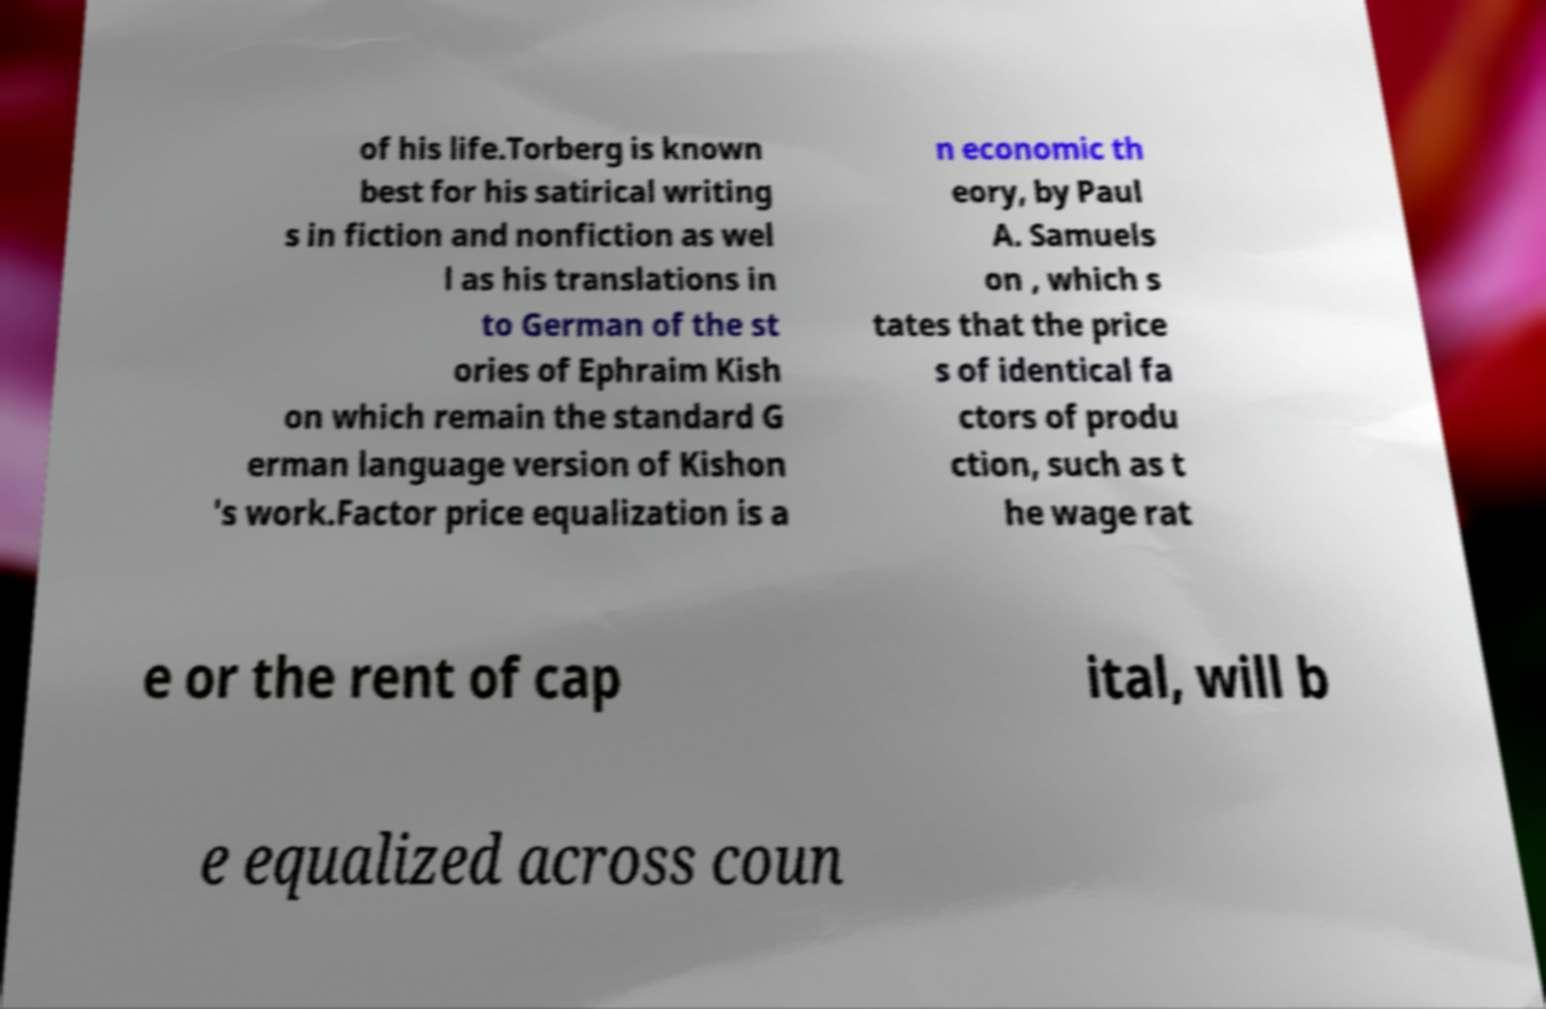Can you read and provide the text displayed in the image?This photo seems to have some interesting text. Can you extract and type it out for me? of his life.Torberg is known best for his satirical writing s in fiction and nonfiction as wel l as his translations in to German of the st ories of Ephraim Kish on which remain the standard G erman language version of Kishon 's work.Factor price equalization is a n economic th eory, by Paul A. Samuels on , which s tates that the price s of identical fa ctors of produ ction, such as t he wage rat e or the rent of cap ital, will b e equalized across coun 